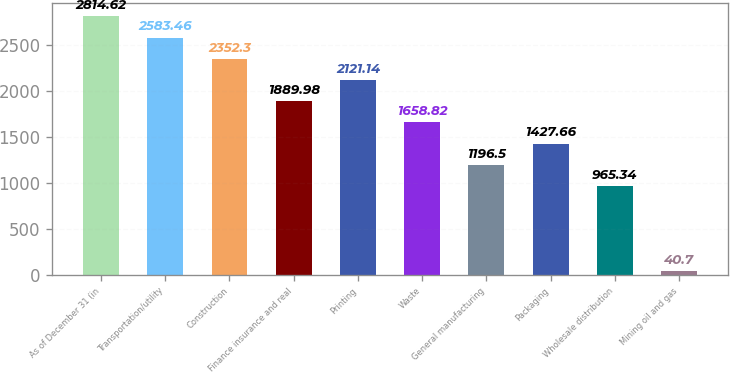Convert chart to OTSL. <chart><loc_0><loc_0><loc_500><loc_500><bar_chart><fcel>As of December 31 (in<fcel>Transportation/utility<fcel>Construction<fcel>Finance insurance and real<fcel>Printing<fcel>Waste<fcel>General manufacturing<fcel>Packaging<fcel>Wholesale distribution<fcel>Mining oil and gas<nl><fcel>2814.62<fcel>2583.46<fcel>2352.3<fcel>1889.98<fcel>2121.14<fcel>1658.82<fcel>1196.5<fcel>1427.66<fcel>965.34<fcel>40.7<nl></chart> 